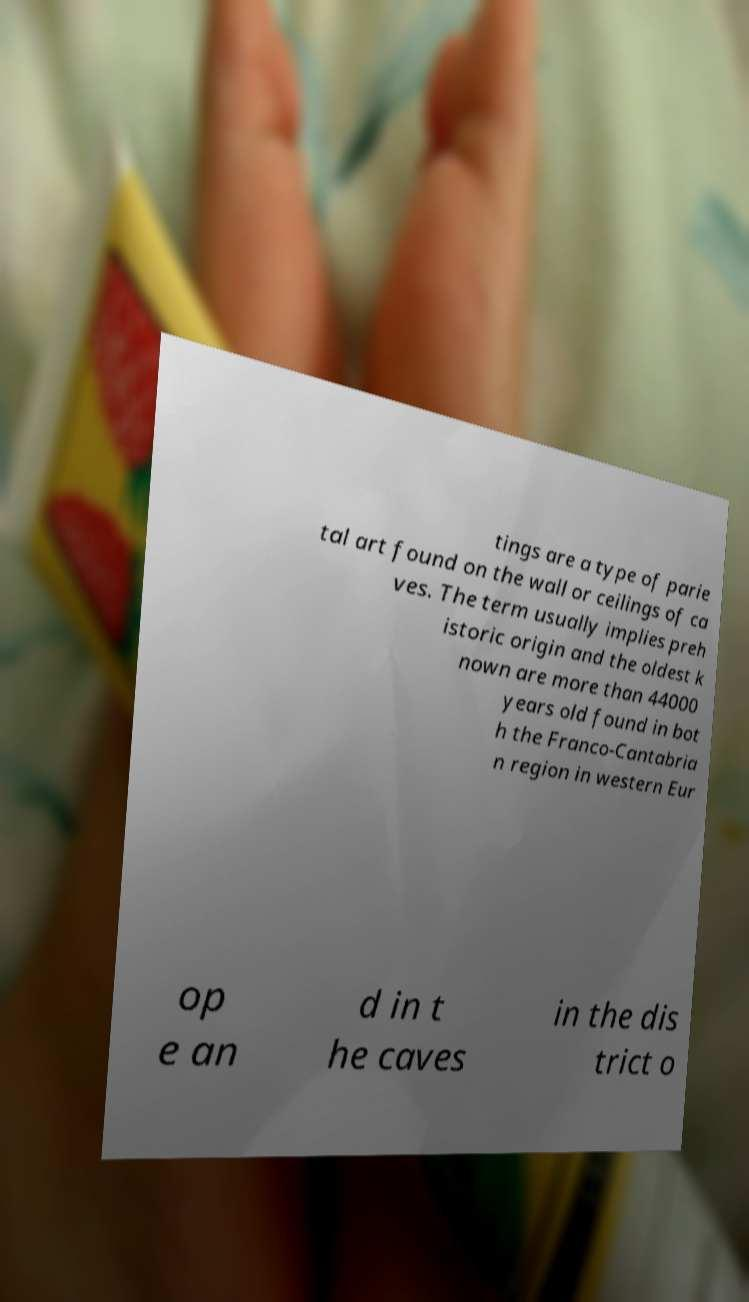I need the written content from this picture converted into text. Can you do that? tings are a type of parie tal art found on the wall or ceilings of ca ves. The term usually implies preh istoric origin and the oldest k nown are more than 44000 years old found in bot h the Franco-Cantabria n region in western Eur op e an d in t he caves in the dis trict o 